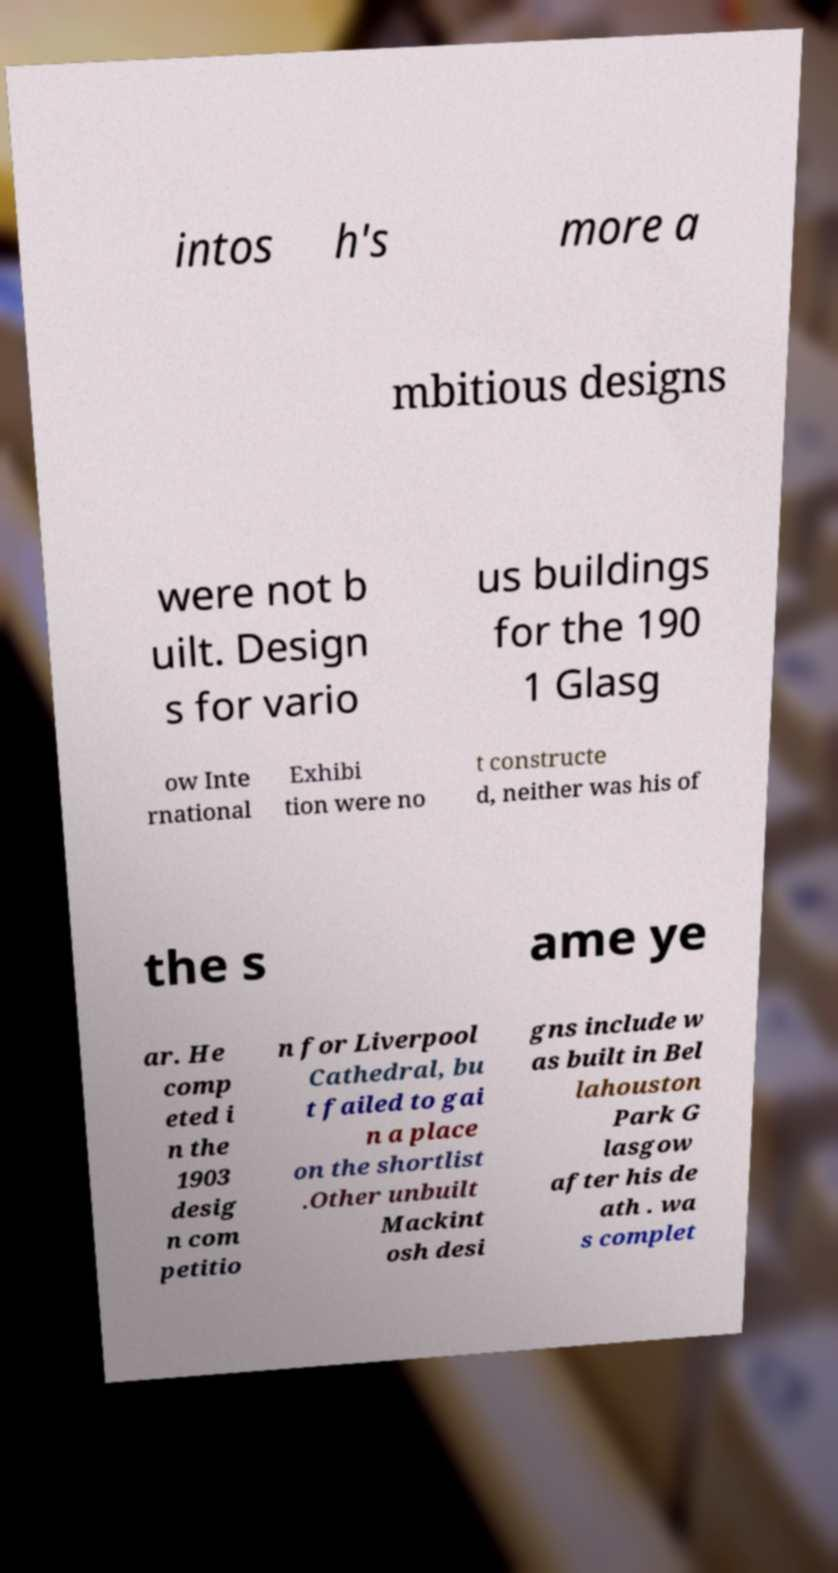Please read and relay the text visible in this image. What does it say? intos h's more a mbitious designs were not b uilt. Design s for vario us buildings for the 190 1 Glasg ow Inte rnational Exhibi tion were no t constructe d, neither was his of the s ame ye ar. He comp eted i n the 1903 desig n com petitio n for Liverpool Cathedral, bu t failed to gai n a place on the shortlist .Other unbuilt Mackint osh desi gns include w as built in Bel lahouston Park G lasgow after his de ath . wa s complet 